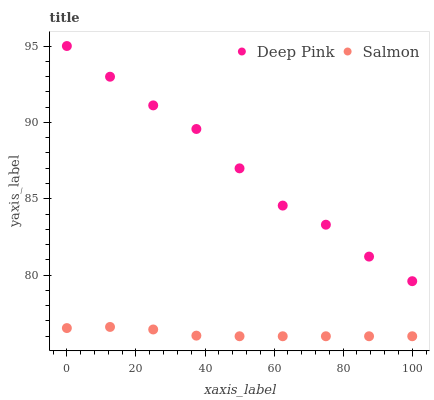Does Salmon have the minimum area under the curve?
Answer yes or no. Yes. Does Deep Pink have the maximum area under the curve?
Answer yes or no. Yes. Does Salmon have the maximum area under the curve?
Answer yes or no. No. Is Salmon the smoothest?
Answer yes or no. Yes. Is Deep Pink the roughest?
Answer yes or no. Yes. Is Salmon the roughest?
Answer yes or no. No. Does Salmon have the lowest value?
Answer yes or no. Yes. Does Deep Pink have the highest value?
Answer yes or no. Yes. Does Salmon have the highest value?
Answer yes or no. No. Is Salmon less than Deep Pink?
Answer yes or no. Yes. Is Deep Pink greater than Salmon?
Answer yes or no. Yes. Does Salmon intersect Deep Pink?
Answer yes or no. No. 